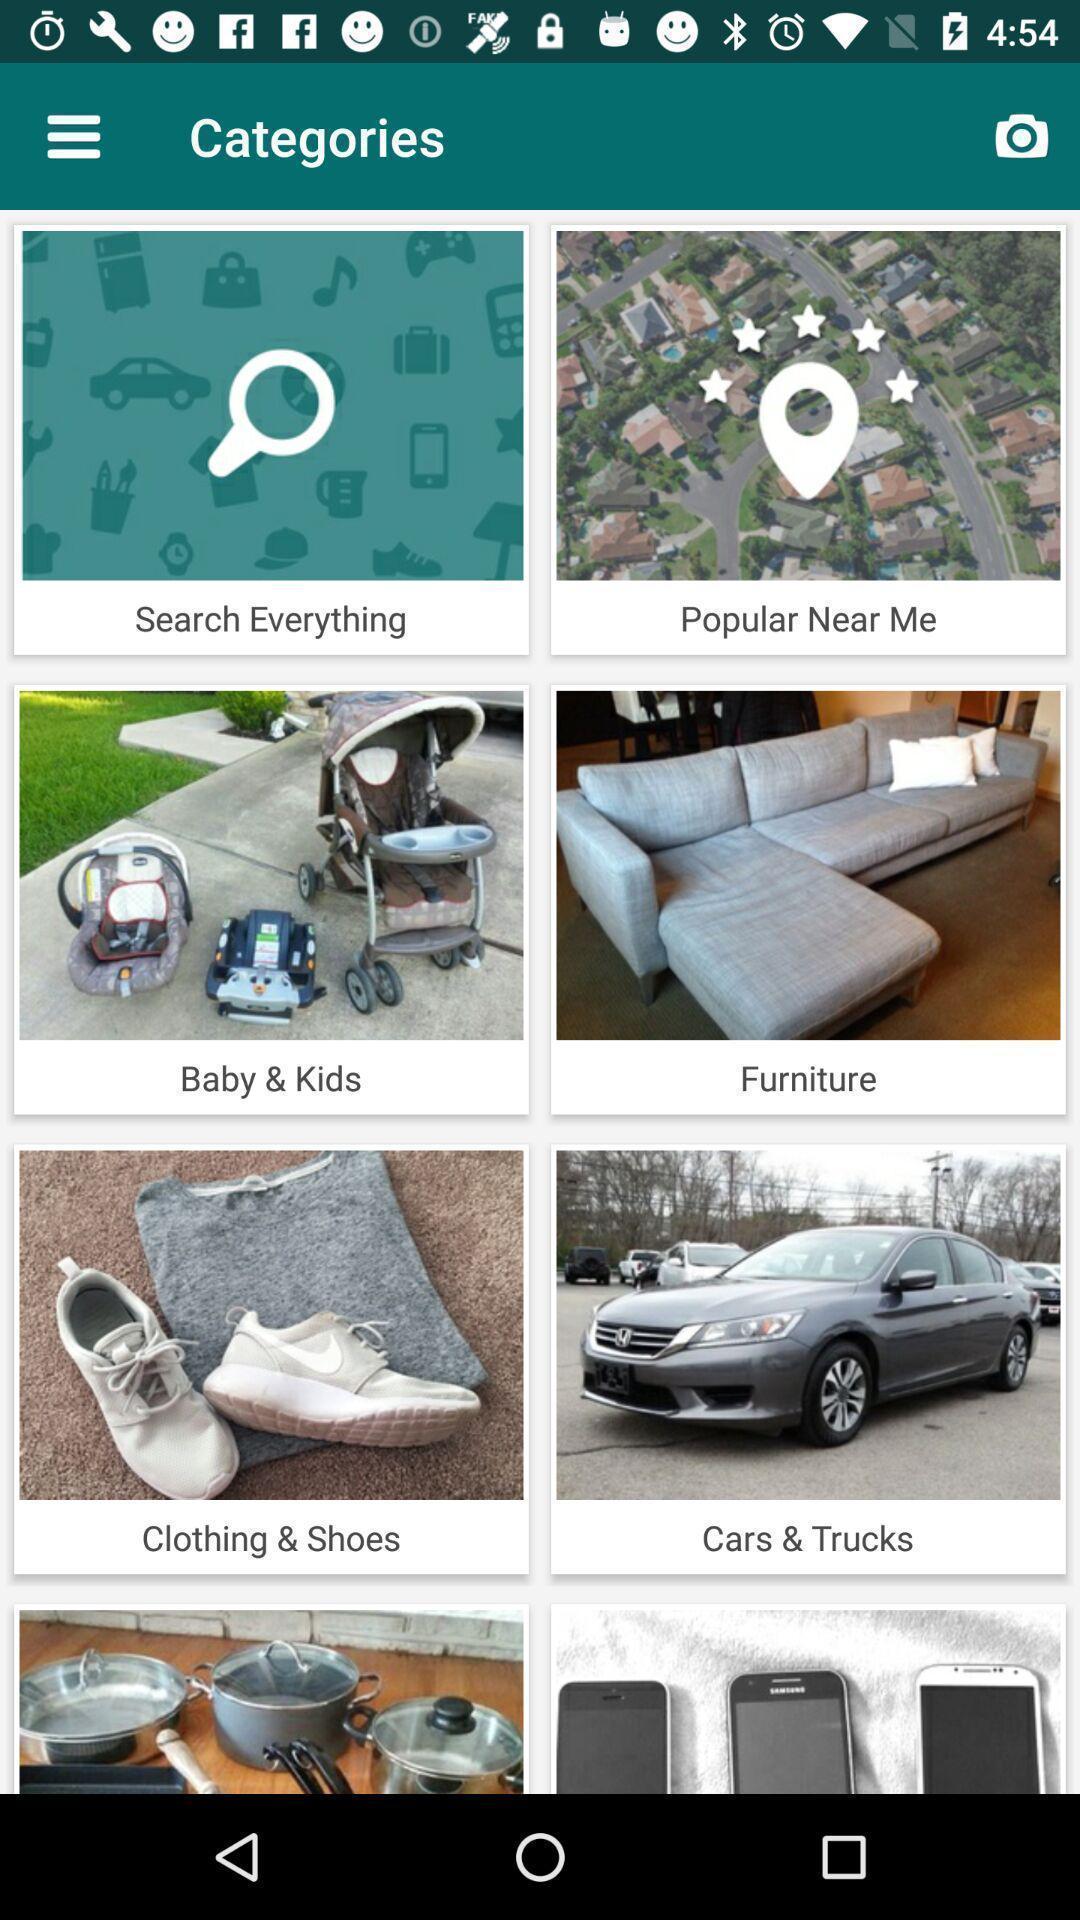Describe this image in words. Screen displaying the various categories. 